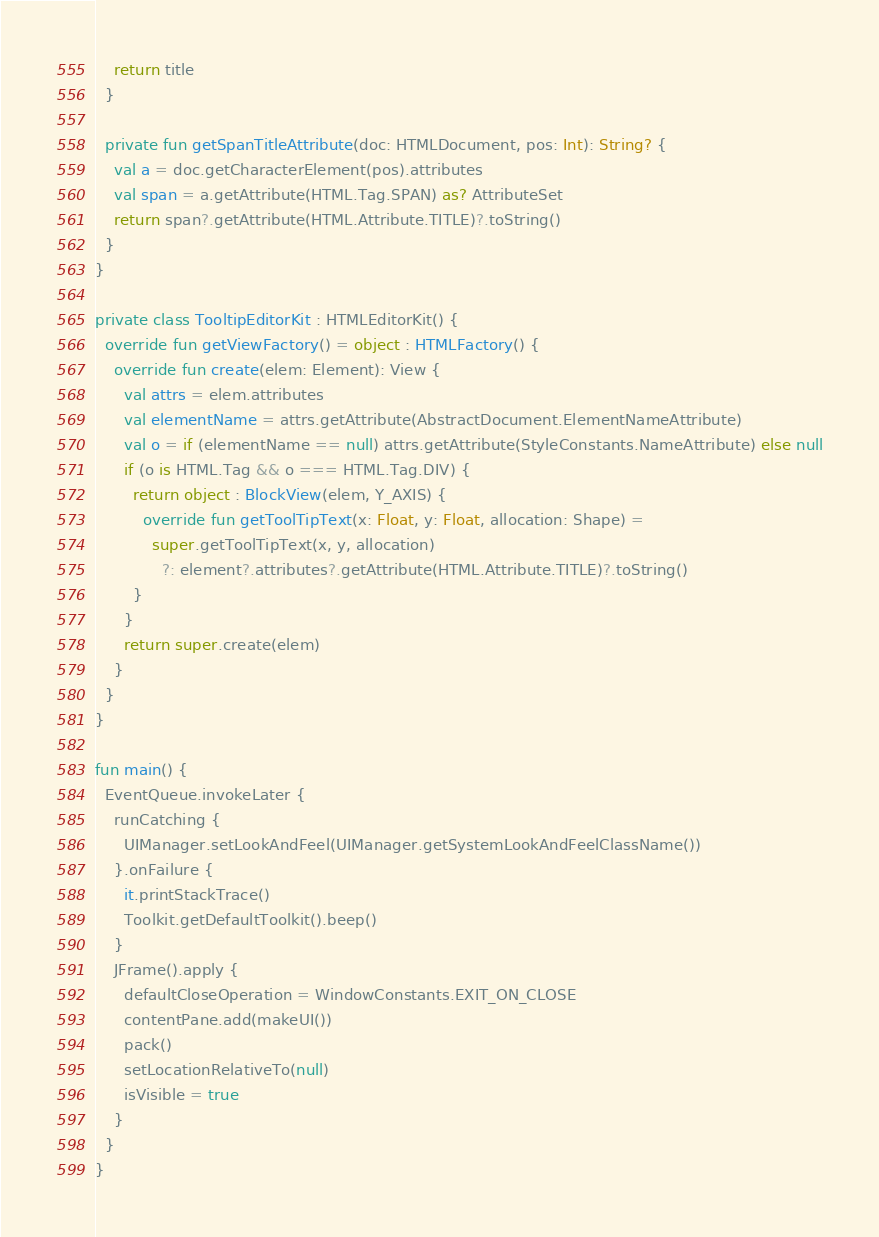Convert code to text. <code><loc_0><loc_0><loc_500><loc_500><_Kotlin_>    return title
  }

  private fun getSpanTitleAttribute(doc: HTMLDocument, pos: Int): String? {
    val a = doc.getCharacterElement(pos).attributes
    val span = a.getAttribute(HTML.Tag.SPAN) as? AttributeSet
    return span?.getAttribute(HTML.Attribute.TITLE)?.toString()
  }
}

private class TooltipEditorKit : HTMLEditorKit() {
  override fun getViewFactory() = object : HTMLFactory() {
    override fun create(elem: Element): View {
      val attrs = elem.attributes
      val elementName = attrs.getAttribute(AbstractDocument.ElementNameAttribute)
      val o = if (elementName == null) attrs.getAttribute(StyleConstants.NameAttribute) else null
      if (o is HTML.Tag && o === HTML.Tag.DIV) {
        return object : BlockView(elem, Y_AXIS) {
          override fun getToolTipText(x: Float, y: Float, allocation: Shape) =
            super.getToolTipText(x, y, allocation)
              ?: element?.attributes?.getAttribute(HTML.Attribute.TITLE)?.toString()
        }
      }
      return super.create(elem)
    }
  }
}

fun main() {
  EventQueue.invokeLater {
    runCatching {
      UIManager.setLookAndFeel(UIManager.getSystemLookAndFeelClassName())
    }.onFailure {
      it.printStackTrace()
      Toolkit.getDefaultToolkit().beep()
    }
    JFrame().apply {
      defaultCloseOperation = WindowConstants.EXIT_ON_CLOSE
      contentPane.add(makeUI())
      pack()
      setLocationRelativeTo(null)
      isVisible = true
    }
  }
}
</code> 